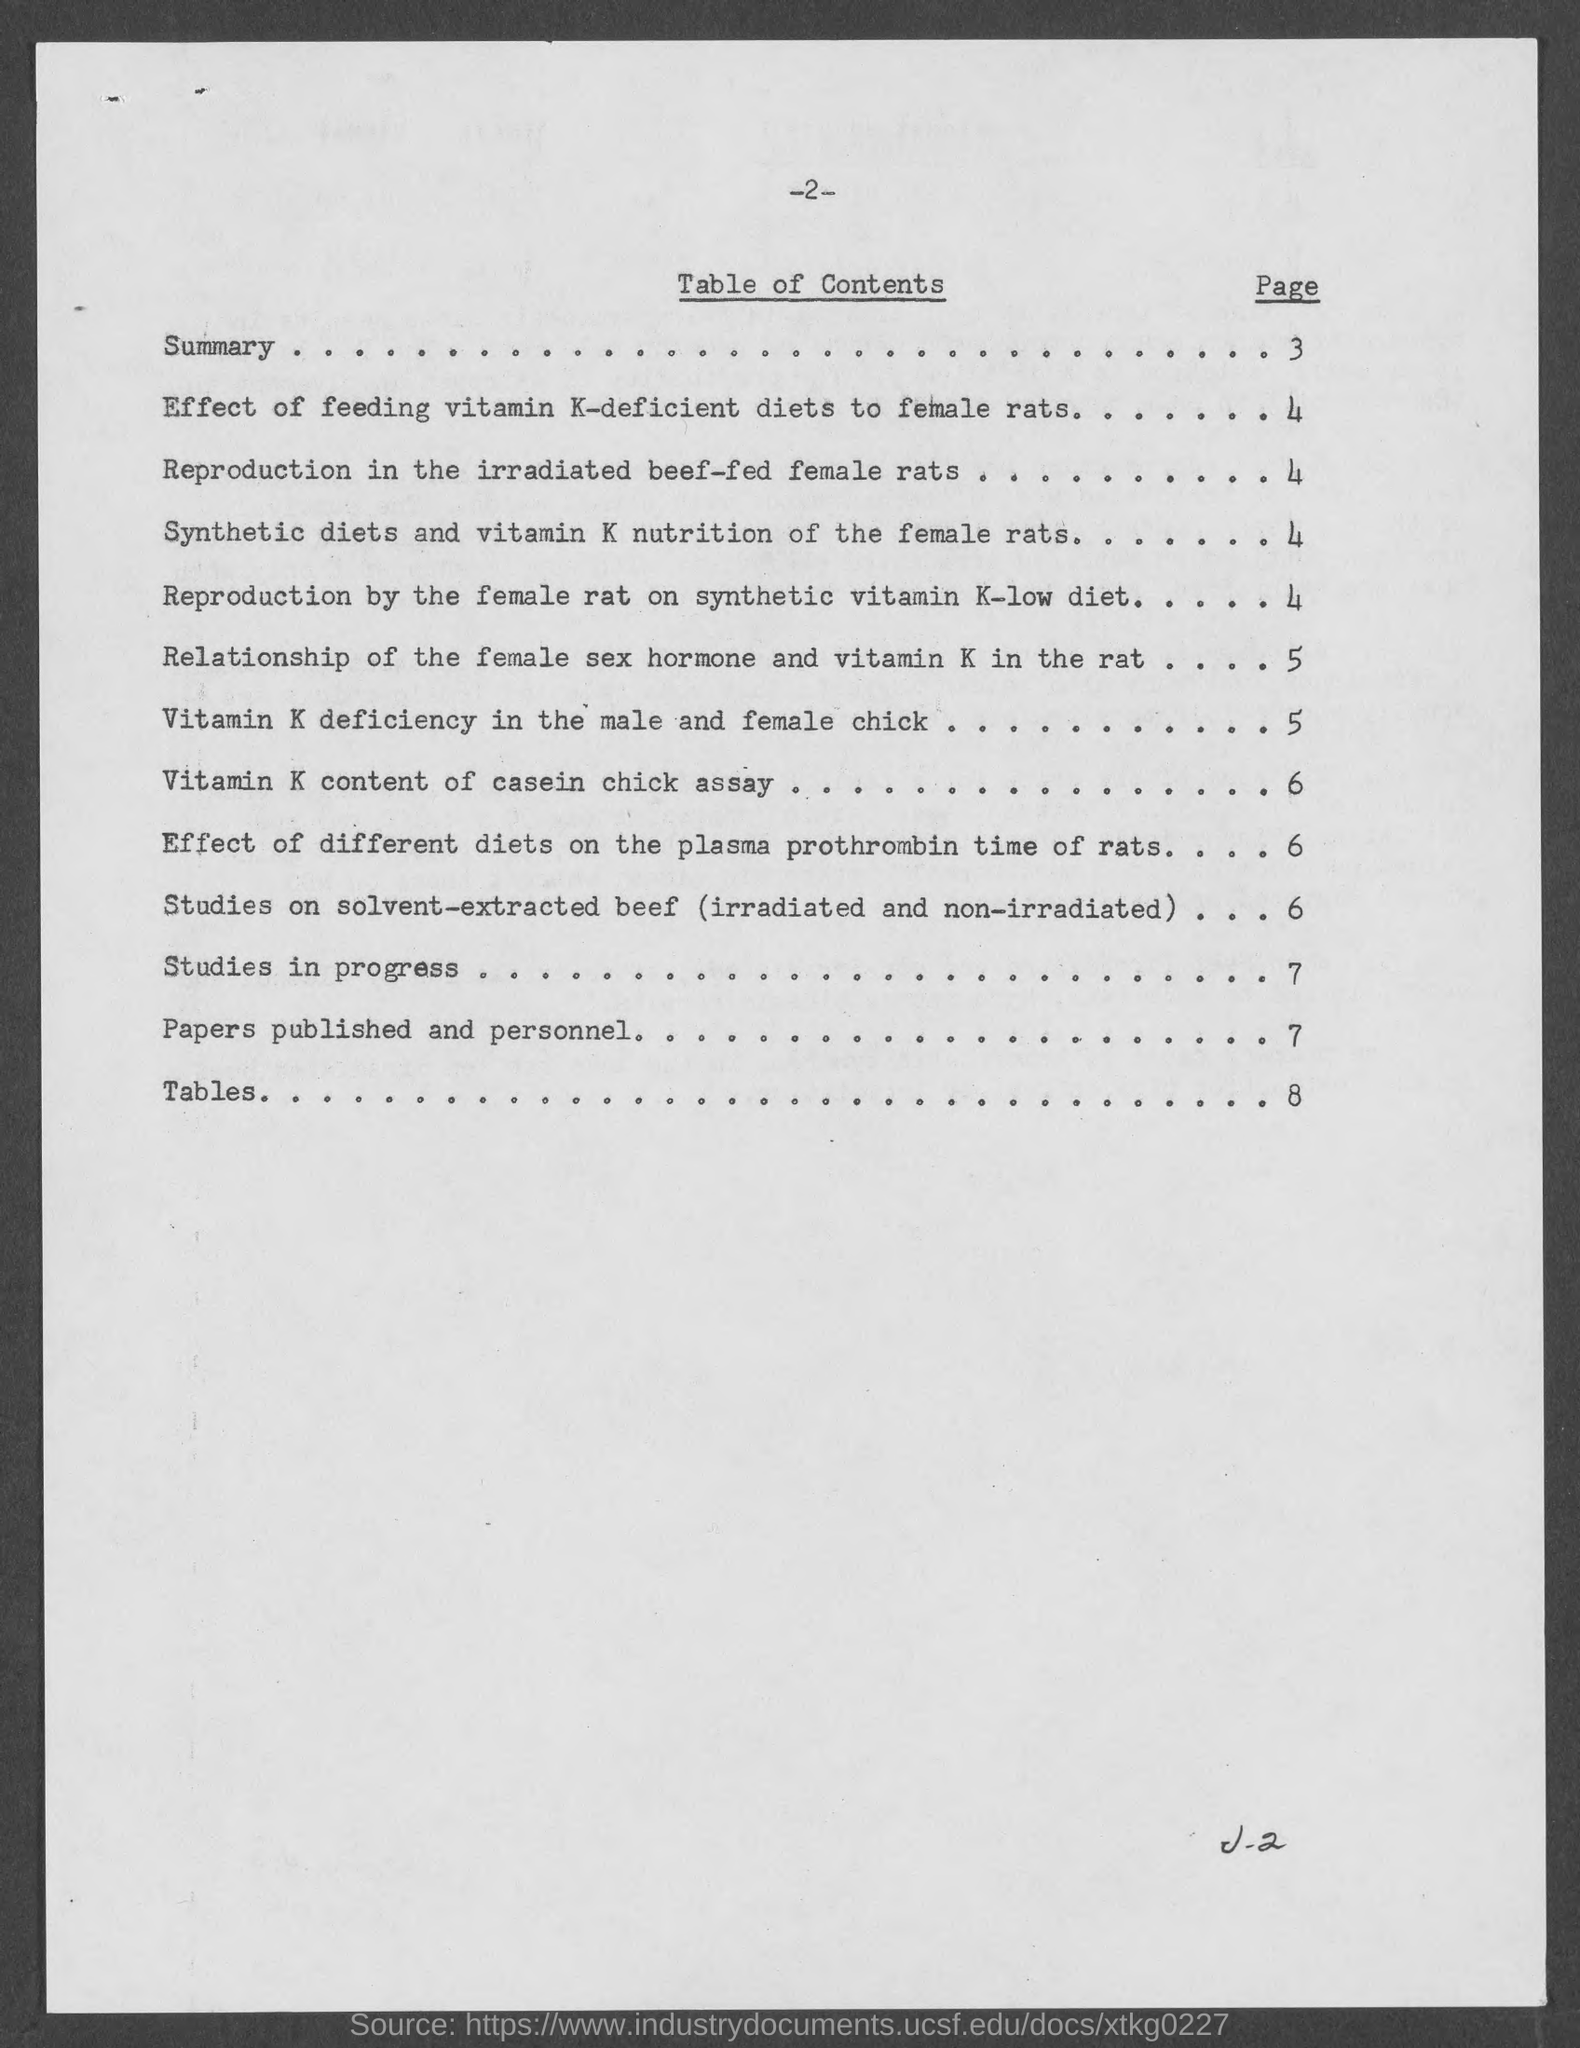List a handful of essential elements in this visual. The page number where the word 'Tables' can be found is 8. Se puede encontrar "Studies in Progress" en la página 7. The page number on which the summary can be found is between 3 and . 